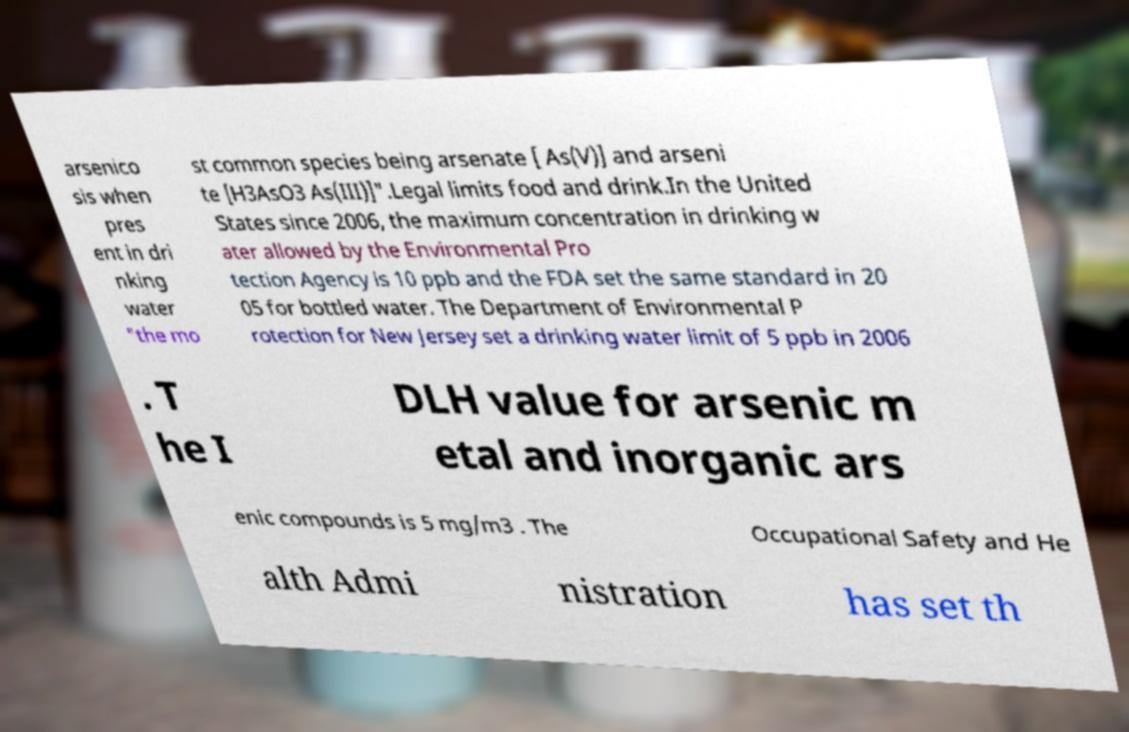Can you accurately transcribe the text from the provided image for me? arsenico sis when pres ent in dri nking water "the mo st common species being arsenate [ As(V)] and arseni te [H3AsO3 As(III)]".Legal limits food and drink.In the United States since 2006, the maximum concentration in drinking w ater allowed by the Environmental Pro tection Agency is 10 ppb and the FDA set the same standard in 20 05 for bottled water. The Department of Environmental P rotection for New Jersey set a drinking water limit of 5 ppb in 2006 . T he I DLH value for arsenic m etal and inorganic ars enic compounds is 5 mg/m3 . The Occupational Safety and He alth Admi nistration has set th 